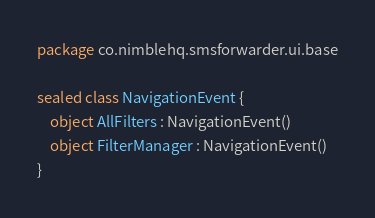<code> <loc_0><loc_0><loc_500><loc_500><_Kotlin_>package co.nimblehq.smsforwarder.ui.base

sealed class NavigationEvent {
    object AllFilters : NavigationEvent()
    object FilterManager : NavigationEvent()
}
</code> 